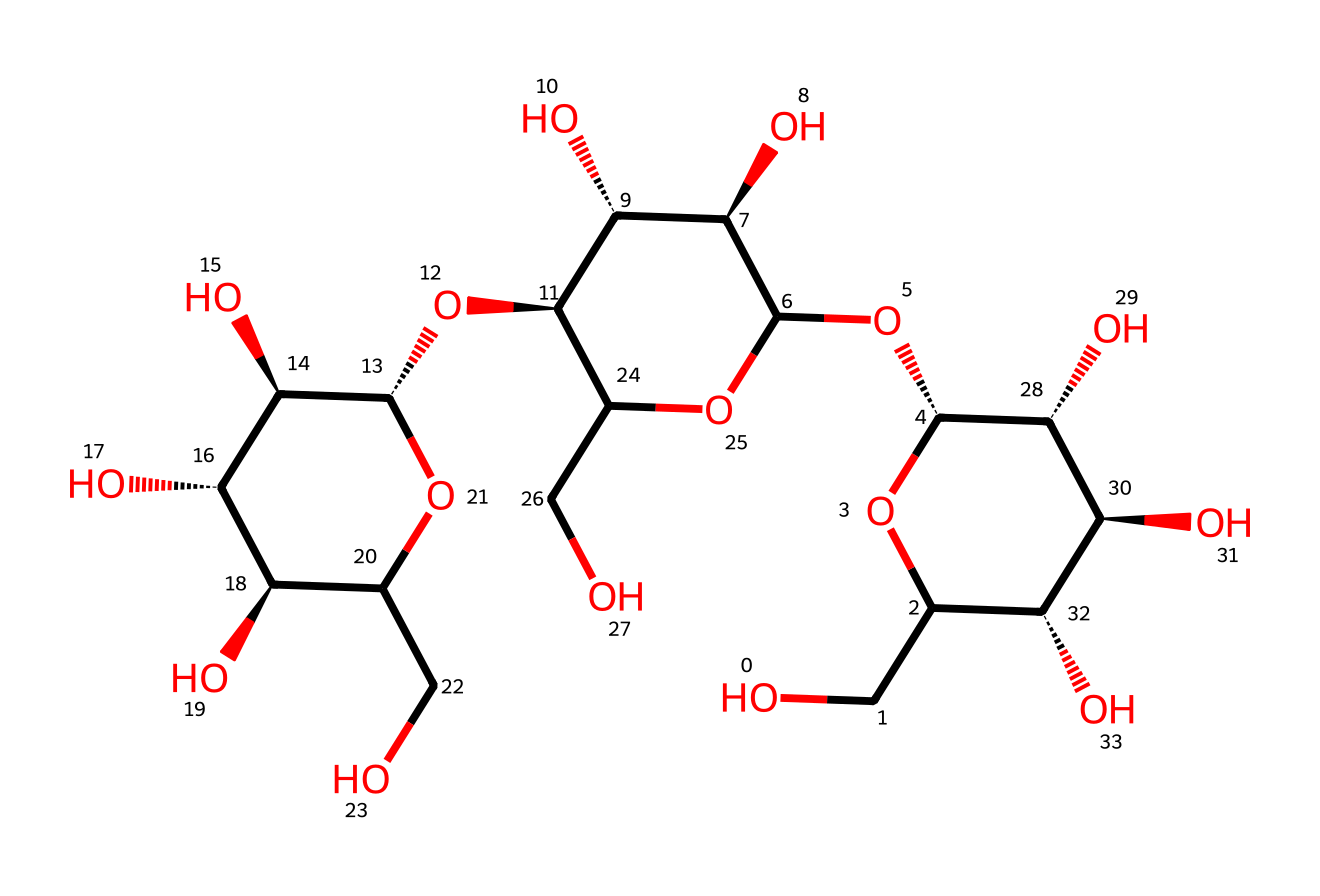How many carbon atoms are in this chemical structure? Counting the carbon atoms in the provided SMILES notation, you can identify the number of CH groups, which correspond to carbon. The structure shows a total of 6 carbon units in the complex arrangement.
Answer: six What is the main functional group in this compound? Analyzing the given SMILES, the structure contains multiple hydroxyl (-OH) groups, which define it primarily as a polyol or sugar alcohol. This highlights its alcohol characteristics.
Answer: hydroxyl Does this compound have a cyclic structure? Observing the SMILES representation, the presence of square brackets indicates cyclic formations where atoms connect to form closed loops. Hence, it's evident that the structure exhibits a cyclic nature.
Answer: yes How many hydroxyl groups are present in this chemical? By directly counting the occurrences of the hydroxyl (-OH) groups indicated within the SMILES string, there are a total of 8 hydroxyl groups present that contribute to its reactivity and solubility in water.
Answer: eight Is this compound a polysaccharide? Since the structure exhibits multiple interconnected sugar units and a high number of hydroxyl groups, confirming its classification as a polysaccharide due to its multiple saccharide constituents is valid.
Answer: yes What type of bonding predominates in this compound? The composition of the structure suggests that it has a significant number of covalent bonds, as is typical in carbohydrate structures, meaning individual atoms are sharing electrons among one another.
Answer: covalent 